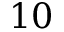Convert formula to latex. <formula><loc_0><loc_0><loc_500><loc_500>1 0</formula> 